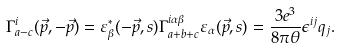Convert formula to latex. <formula><loc_0><loc_0><loc_500><loc_500>\Gamma _ { a - c } ^ { i } ( \vec { p } , - \vec { p } ) = \varepsilon _ { \beta } ^ { * } ( - \vec { p } , s ) \Gamma _ { a + b + c } ^ { i \alpha \beta } \varepsilon _ { \alpha } ( \vec { p } , s ) = \frac { 3 e ^ { 3 } } { 8 \pi \theta } \epsilon ^ { i j } q _ { j } .</formula> 